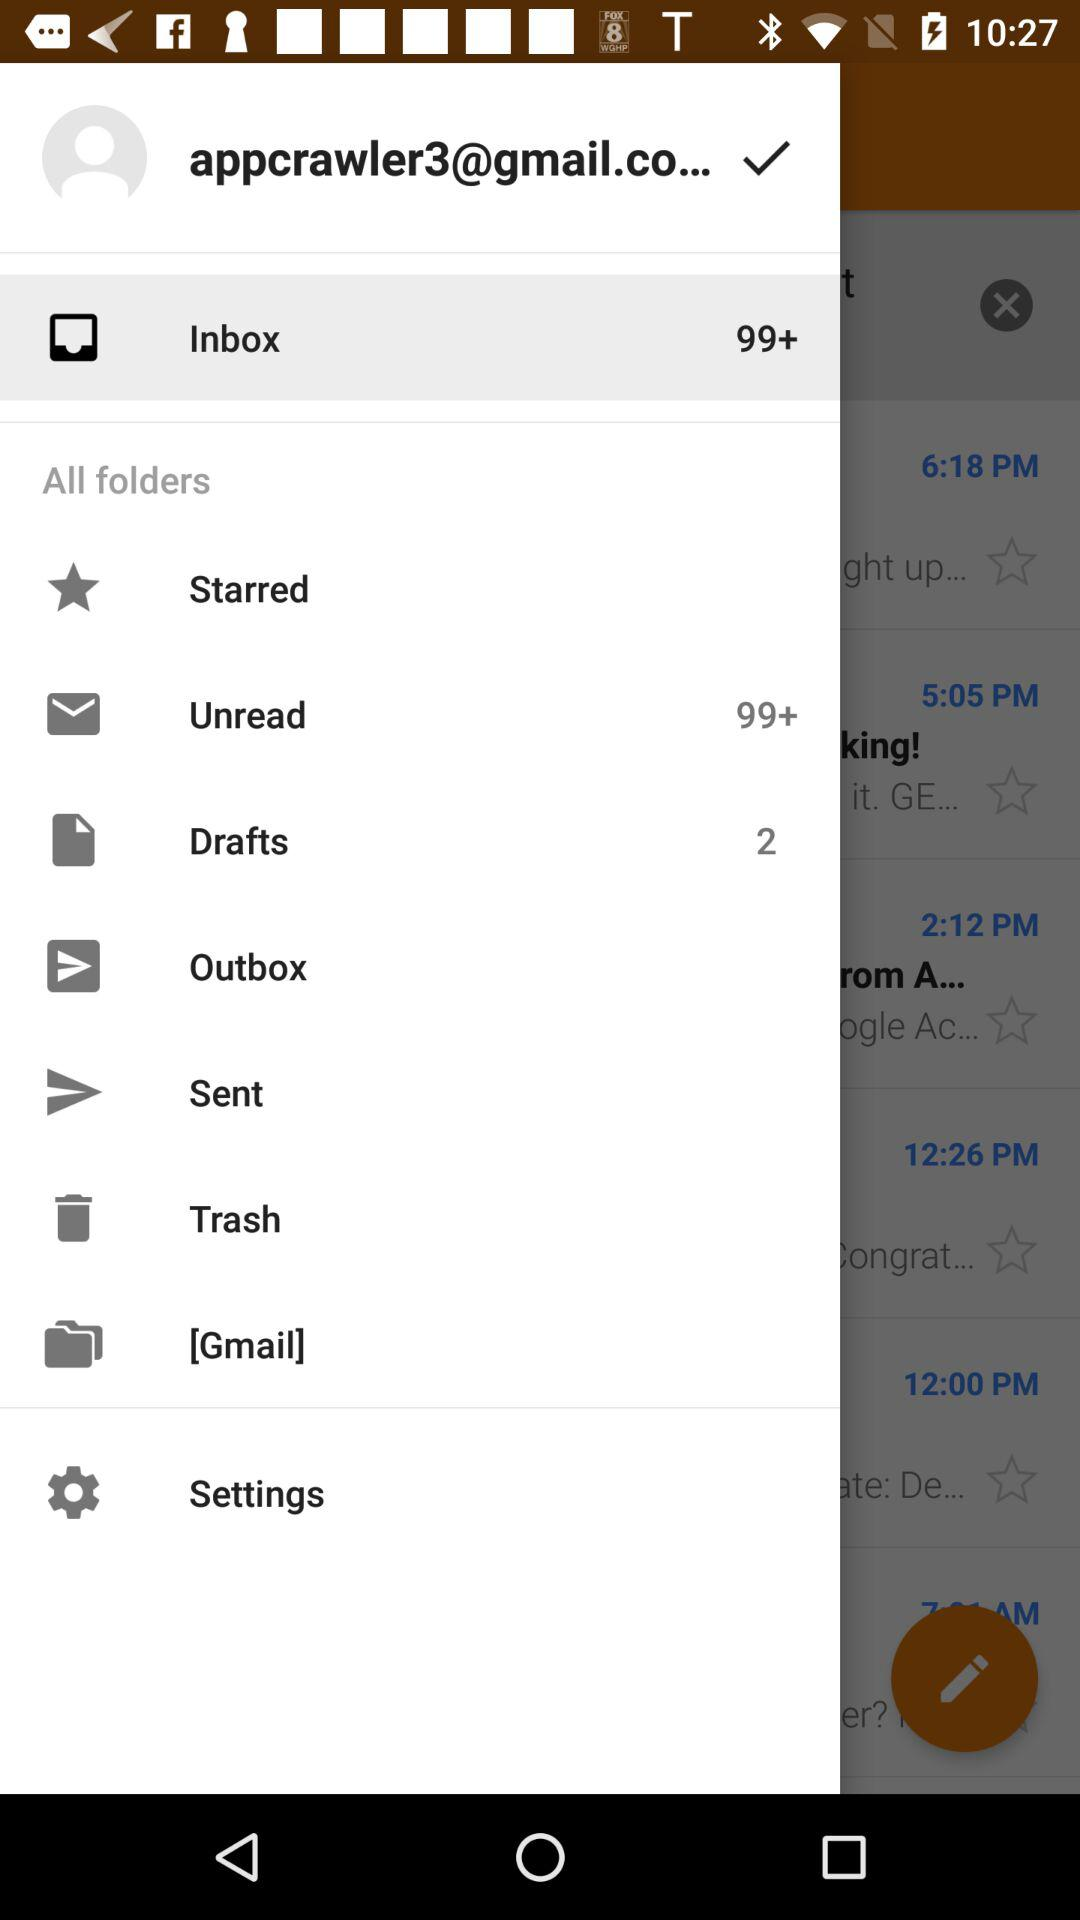What is the email address? The email address is "appcrawler3@gmail.co...". 